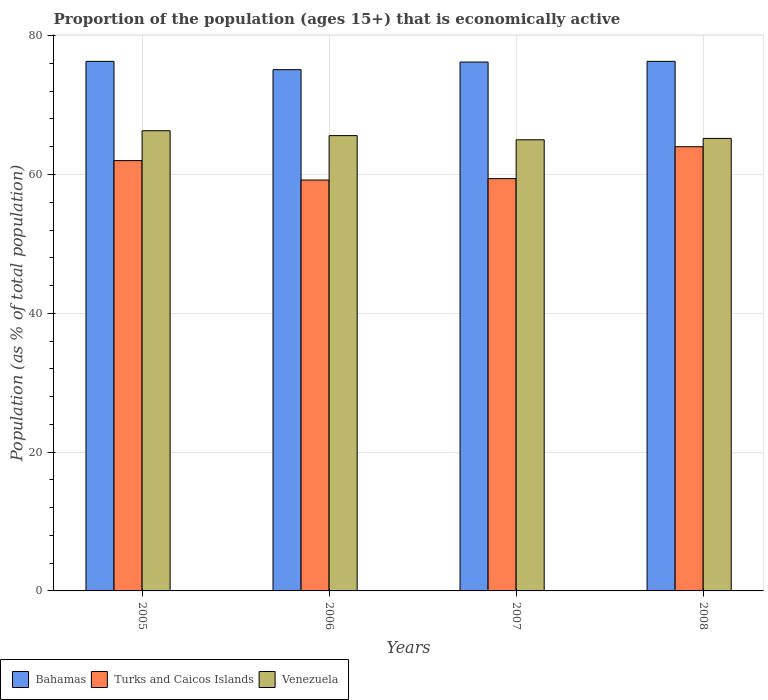How many groups of bars are there?
Make the answer very short. 4. Are the number of bars per tick equal to the number of legend labels?
Your response must be concise. Yes. How many bars are there on the 4th tick from the left?
Provide a succinct answer. 3. What is the proportion of the population that is economically active in Venezuela in 2008?
Offer a very short reply. 65.2. Across all years, what is the maximum proportion of the population that is economically active in Venezuela?
Provide a succinct answer. 66.3. Across all years, what is the minimum proportion of the population that is economically active in Bahamas?
Offer a very short reply. 75.1. What is the total proportion of the population that is economically active in Venezuela in the graph?
Your answer should be compact. 262.1. What is the difference between the proportion of the population that is economically active in Bahamas in 2006 and that in 2007?
Ensure brevity in your answer.  -1.1. What is the difference between the proportion of the population that is economically active in Bahamas in 2007 and the proportion of the population that is economically active in Venezuela in 2005?
Offer a very short reply. 9.9. What is the average proportion of the population that is economically active in Venezuela per year?
Offer a very short reply. 65.52. In the year 2008, what is the difference between the proportion of the population that is economically active in Venezuela and proportion of the population that is economically active in Turks and Caicos Islands?
Keep it short and to the point. 1.2. In how many years, is the proportion of the population that is economically active in Venezuela greater than 24 %?
Your response must be concise. 4. What is the difference between the highest and the second highest proportion of the population that is economically active in Venezuela?
Make the answer very short. 0.7. What is the difference between the highest and the lowest proportion of the population that is economically active in Turks and Caicos Islands?
Ensure brevity in your answer.  4.8. What does the 1st bar from the left in 2008 represents?
Your response must be concise. Bahamas. What does the 3rd bar from the right in 2005 represents?
Your answer should be very brief. Bahamas. Is it the case that in every year, the sum of the proportion of the population that is economically active in Bahamas and proportion of the population that is economically active in Turks and Caicos Islands is greater than the proportion of the population that is economically active in Venezuela?
Provide a succinct answer. Yes. How many bars are there?
Offer a terse response. 12. How many years are there in the graph?
Keep it short and to the point. 4. What is the difference between two consecutive major ticks on the Y-axis?
Make the answer very short. 20. Does the graph contain any zero values?
Offer a very short reply. No. How are the legend labels stacked?
Make the answer very short. Horizontal. What is the title of the graph?
Keep it short and to the point. Proportion of the population (ages 15+) that is economically active. What is the label or title of the X-axis?
Provide a succinct answer. Years. What is the label or title of the Y-axis?
Your response must be concise. Population (as % of total population). What is the Population (as % of total population) of Bahamas in 2005?
Provide a short and direct response. 76.3. What is the Population (as % of total population) in Venezuela in 2005?
Keep it short and to the point. 66.3. What is the Population (as % of total population) of Bahamas in 2006?
Give a very brief answer. 75.1. What is the Population (as % of total population) in Turks and Caicos Islands in 2006?
Give a very brief answer. 59.2. What is the Population (as % of total population) of Venezuela in 2006?
Give a very brief answer. 65.6. What is the Population (as % of total population) of Bahamas in 2007?
Provide a succinct answer. 76.2. What is the Population (as % of total population) of Turks and Caicos Islands in 2007?
Your response must be concise. 59.4. What is the Population (as % of total population) in Bahamas in 2008?
Keep it short and to the point. 76.3. What is the Population (as % of total population) in Venezuela in 2008?
Keep it short and to the point. 65.2. Across all years, what is the maximum Population (as % of total population) of Bahamas?
Keep it short and to the point. 76.3. Across all years, what is the maximum Population (as % of total population) of Turks and Caicos Islands?
Provide a short and direct response. 64. Across all years, what is the maximum Population (as % of total population) of Venezuela?
Make the answer very short. 66.3. Across all years, what is the minimum Population (as % of total population) of Bahamas?
Your response must be concise. 75.1. Across all years, what is the minimum Population (as % of total population) of Turks and Caicos Islands?
Your answer should be compact. 59.2. What is the total Population (as % of total population) in Bahamas in the graph?
Your answer should be compact. 303.9. What is the total Population (as % of total population) of Turks and Caicos Islands in the graph?
Keep it short and to the point. 244.6. What is the total Population (as % of total population) in Venezuela in the graph?
Make the answer very short. 262.1. What is the difference between the Population (as % of total population) in Bahamas in 2005 and that in 2006?
Provide a succinct answer. 1.2. What is the difference between the Population (as % of total population) of Venezuela in 2005 and that in 2006?
Ensure brevity in your answer.  0.7. What is the difference between the Population (as % of total population) in Venezuela in 2005 and that in 2007?
Provide a short and direct response. 1.3. What is the difference between the Population (as % of total population) in Venezuela in 2005 and that in 2008?
Make the answer very short. 1.1. What is the difference between the Population (as % of total population) in Turks and Caicos Islands in 2006 and that in 2007?
Offer a terse response. -0.2. What is the difference between the Population (as % of total population) of Venezuela in 2006 and that in 2007?
Ensure brevity in your answer.  0.6. What is the difference between the Population (as % of total population) in Bahamas in 2006 and that in 2008?
Offer a very short reply. -1.2. What is the difference between the Population (as % of total population) in Bahamas in 2007 and that in 2008?
Your response must be concise. -0.1. What is the difference between the Population (as % of total population) of Bahamas in 2005 and the Population (as % of total population) of Turks and Caicos Islands in 2006?
Keep it short and to the point. 17.1. What is the difference between the Population (as % of total population) in Turks and Caicos Islands in 2005 and the Population (as % of total population) in Venezuela in 2006?
Give a very brief answer. -3.6. What is the difference between the Population (as % of total population) in Bahamas in 2005 and the Population (as % of total population) in Turks and Caicos Islands in 2007?
Make the answer very short. 16.9. What is the difference between the Population (as % of total population) in Bahamas in 2005 and the Population (as % of total population) in Venezuela in 2007?
Ensure brevity in your answer.  11.3. What is the difference between the Population (as % of total population) in Turks and Caicos Islands in 2005 and the Population (as % of total population) in Venezuela in 2007?
Give a very brief answer. -3. What is the difference between the Population (as % of total population) of Bahamas in 2005 and the Population (as % of total population) of Turks and Caicos Islands in 2008?
Offer a very short reply. 12.3. What is the difference between the Population (as % of total population) of Turks and Caicos Islands in 2005 and the Population (as % of total population) of Venezuela in 2008?
Make the answer very short. -3.2. What is the difference between the Population (as % of total population) of Bahamas in 2006 and the Population (as % of total population) of Venezuela in 2007?
Provide a succinct answer. 10.1. What is the difference between the Population (as % of total population) of Bahamas in 2006 and the Population (as % of total population) of Turks and Caicos Islands in 2008?
Offer a terse response. 11.1. What is the difference between the Population (as % of total population) in Bahamas in 2006 and the Population (as % of total population) in Venezuela in 2008?
Offer a terse response. 9.9. What is the difference between the Population (as % of total population) of Turks and Caicos Islands in 2006 and the Population (as % of total population) of Venezuela in 2008?
Offer a terse response. -6. What is the difference between the Population (as % of total population) of Bahamas in 2007 and the Population (as % of total population) of Turks and Caicos Islands in 2008?
Your answer should be very brief. 12.2. What is the difference between the Population (as % of total population) of Turks and Caicos Islands in 2007 and the Population (as % of total population) of Venezuela in 2008?
Your response must be concise. -5.8. What is the average Population (as % of total population) of Bahamas per year?
Your answer should be very brief. 75.97. What is the average Population (as % of total population) of Turks and Caicos Islands per year?
Offer a terse response. 61.15. What is the average Population (as % of total population) of Venezuela per year?
Give a very brief answer. 65.53. In the year 2005, what is the difference between the Population (as % of total population) of Bahamas and Population (as % of total population) of Turks and Caicos Islands?
Provide a short and direct response. 14.3. In the year 2005, what is the difference between the Population (as % of total population) in Turks and Caicos Islands and Population (as % of total population) in Venezuela?
Keep it short and to the point. -4.3. In the year 2006, what is the difference between the Population (as % of total population) of Bahamas and Population (as % of total population) of Turks and Caicos Islands?
Provide a succinct answer. 15.9. In the year 2006, what is the difference between the Population (as % of total population) of Bahamas and Population (as % of total population) of Venezuela?
Give a very brief answer. 9.5. In the year 2006, what is the difference between the Population (as % of total population) in Turks and Caicos Islands and Population (as % of total population) in Venezuela?
Your answer should be compact. -6.4. In the year 2007, what is the difference between the Population (as % of total population) of Bahamas and Population (as % of total population) of Venezuela?
Offer a terse response. 11.2. In the year 2007, what is the difference between the Population (as % of total population) in Turks and Caicos Islands and Population (as % of total population) in Venezuela?
Make the answer very short. -5.6. What is the ratio of the Population (as % of total population) in Bahamas in 2005 to that in 2006?
Your response must be concise. 1.02. What is the ratio of the Population (as % of total population) of Turks and Caicos Islands in 2005 to that in 2006?
Ensure brevity in your answer.  1.05. What is the ratio of the Population (as % of total population) of Venezuela in 2005 to that in 2006?
Make the answer very short. 1.01. What is the ratio of the Population (as % of total population) in Turks and Caicos Islands in 2005 to that in 2007?
Offer a very short reply. 1.04. What is the ratio of the Population (as % of total population) of Bahamas in 2005 to that in 2008?
Give a very brief answer. 1. What is the ratio of the Population (as % of total population) in Turks and Caicos Islands in 2005 to that in 2008?
Provide a short and direct response. 0.97. What is the ratio of the Population (as % of total population) of Venezuela in 2005 to that in 2008?
Your answer should be very brief. 1.02. What is the ratio of the Population (as % of total population) in Bahamas in 2006 to that in 2007?
Offer a very short reply. 0.99. What is the ratio of the Population (as % of total population) in Turks and Caicos Islands in 2006 to that in 2007?
Provide a short and direct response. 1. What is the ratio of the Population (as % of total population) of Venezuela in 2006 to that in 2007?
Your answer should be compact. 1.01. What is the ratio of the Population (as % of total population) in Bahamas in 2006 to that in 2008?
Your response must be concise. 0.98. What is the ratio of the Population (as % of total population) in Turks and Caicos Islands in 2006 to that in 2008?
Offer a terse response. 0.93. What is the ratio of the Population (as % of total population) of Turks and Caicos Islands in 2007 to that in 2008?
Provide a short and direct response. 0.93. What is the ratio of the Population (as % of total population) in Venezuela in 2007 to that in 2008?
Give a very brief answer. 1. What is the difference between the highest and the second highest Population (as % of total population) of Turks and Caicos Islands?
Keep it short and to the point. 2. What is the difference between the highest and the second highest Population (as % of total population) of Venezuela?
Keep it short and to the point. 0.7. What is the difference between the highest and the lowest Population (as % of total population) of Bahamas?
Your response must be concise. 1.2. What is the difference between the highest and the lowest Population (as % of total population) in Turks and Caicos Islands?
Ensure brevity in your answer.  4.8. 